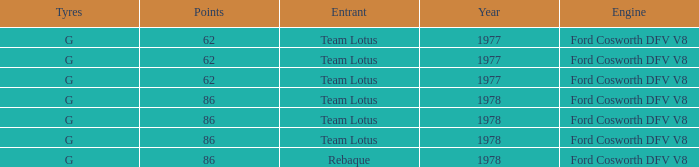What is the Focus that has a Year bigger than 1977? 86, 86, 86, 86. 